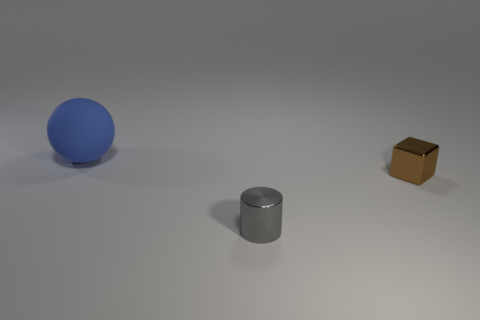How many other things are the same size as the blue sphere?
Make the answer very short. 0. What is the color of the metallic thing behind the gray metallic cylinder?
Provide a succinct answer. Brown. Does the thing in front of the brown block have the same material as the big thing?
Your answer should be very brief. No. What number of things are both in front of the blue object and behind the small brown metal block?
Your response must be concise. 0. The small thing to the left of the tiny object on the right side of the metallic object that is to the left of the brown metallic object is what color?
Provide a succinct answer. Gray. How many other objects are the same shape as the gray thing?
Your response must be concise. 0. Is there a tiny gray shiny cylinder that is in front of the small object on the left side of the small brown block?
Provide a succinct answer. No. How many matte things are either brown cubes or brown spheres?
Give a very brief answer. 0. What is the object that is on the left side of the brown shiny block and behind the gray thing made of?
Offer a very short reply. Rubber. Is there a metallic object that is behind the tiny metal object that is on the left side of the tiny thing that is behind the gray metallic cylinder?
Your response must be concise. Yes. 